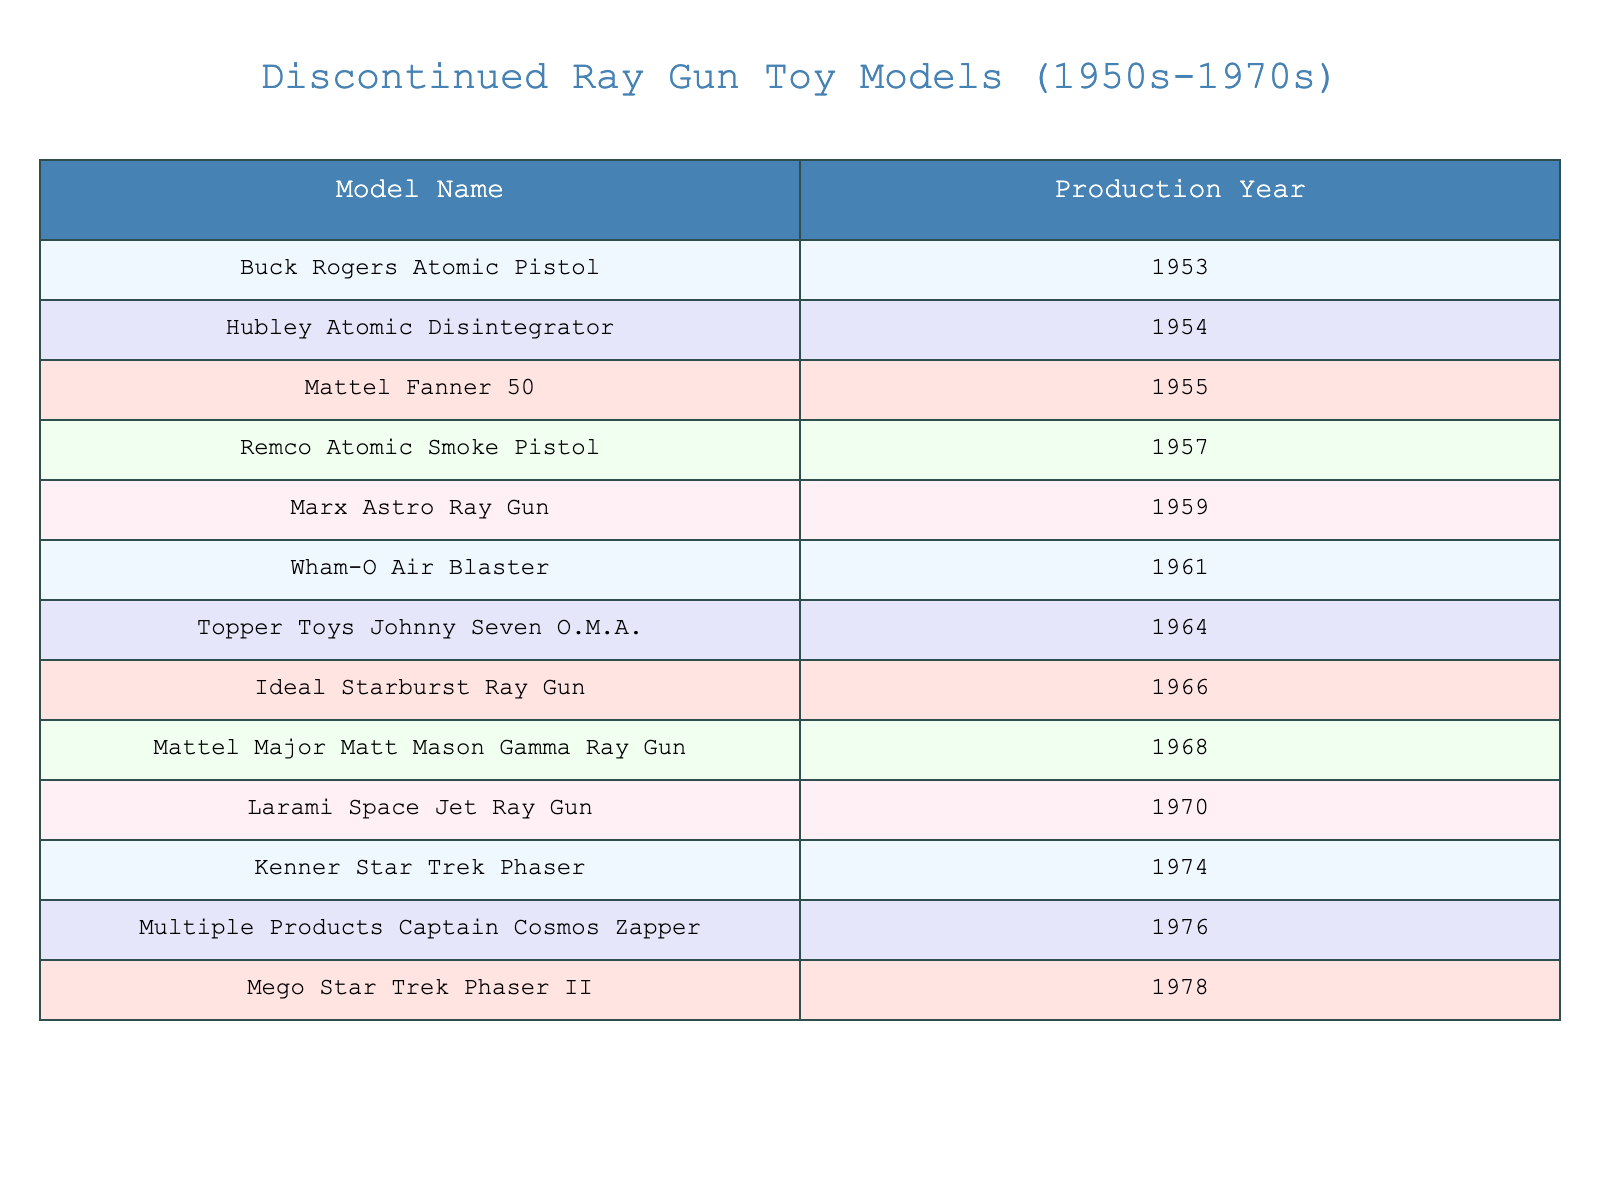What was the first ray gun model released? The table lists the "Buck Rogers Atomic Pistol" as the first model, which was produced in 1953.
Answer: Buck Rogers Atomic Pistol Which ray gun model had the latest production year? The table shows that the "Mego Star Trek Phaser II" was produced in 1978, which is the highest year in the list.
Answer: Mego Star Trek Phaser II How many ray gun models were produced in the 1960s? From the table, the models produced in the 1960s are: "Topper Toys Johnny Seven O.M.A." (1964), "Ideal Starburst Ray Gun" (1966), and "Mattel Major Matt Mason Gamma Ray Gun" (1968), totaling three models.
Answer: 3 Did any ray gun models get produced in the year 1975? The table has no entries for 1975, meaning no ray gun models were produced that year.
Answer: No What is the difference between the earliest and latest production years listed? The earliest production year is 1953 and the latest is 1978. The difference is 1978 - 1953 = 25 years.
Answer: 25 years How many ray gun models were produced in the 1950s compared to the 1960s? There are 6 models from the 1950s: "Buck Rogers Atomic Pistol" (1953), "Hubley Atomic Disintegrator" (1954), "Mattel Fanner 50" (1955), "Remco Atomic Smoke Pistol" (1957), "Marx Astro Ray Gun" (1959), and "Wham-O Air Blaster" (1961); and 3 models from the 1960s. Therefore, 6 is more than 3.
Answer: 6 is more than 3 What was the product name of the ray gun model produced in 1970? According to the table, the ray gun produced in 1970 is the "Larami Space Jet Ray Gun".
Answer: Larami Space Jet Ray Gun Calculate the total number of ray gun models produced in the table. The total number of models listed in the table is 12, as counted directly from the entries.
Answer: 12 Is the "Mattel Major Matt Mason Gamma Ray Gun" one of the models produced in the 1950s? The table indicates that this model was produced in 1968, which is not in the 1950s, therefore the answer is no.
Answer: No How many more ray gun models were produced in the 1970s compared to the 1950s? The table shows 4 models produced in the 1970s and 6 models in the 1950s, so 4 - 6 = -2, indicating 2 fewer models in the 1970s.
Answer: 2 fewer models in the 1970s List the ray guns produced after 1965. The table shows 6 models produced after 1965: "Mattel Major Matt Mason Gamma Ray Gun" (1968), "Larami Space Jet Ray Gun" (1970), "Kenner Star Trek Phaser" (1974), "Multiple Products Captain Cosmos Zapper" (1976), and "Mego Star Trek Phaser II" (1978).
Answer: 5 models What was the production year of the "Marx Astro Ray Gun"? The table clearly states that the "Marx Astro Ray Gun" was produced in 1959.
Answer: 1959 